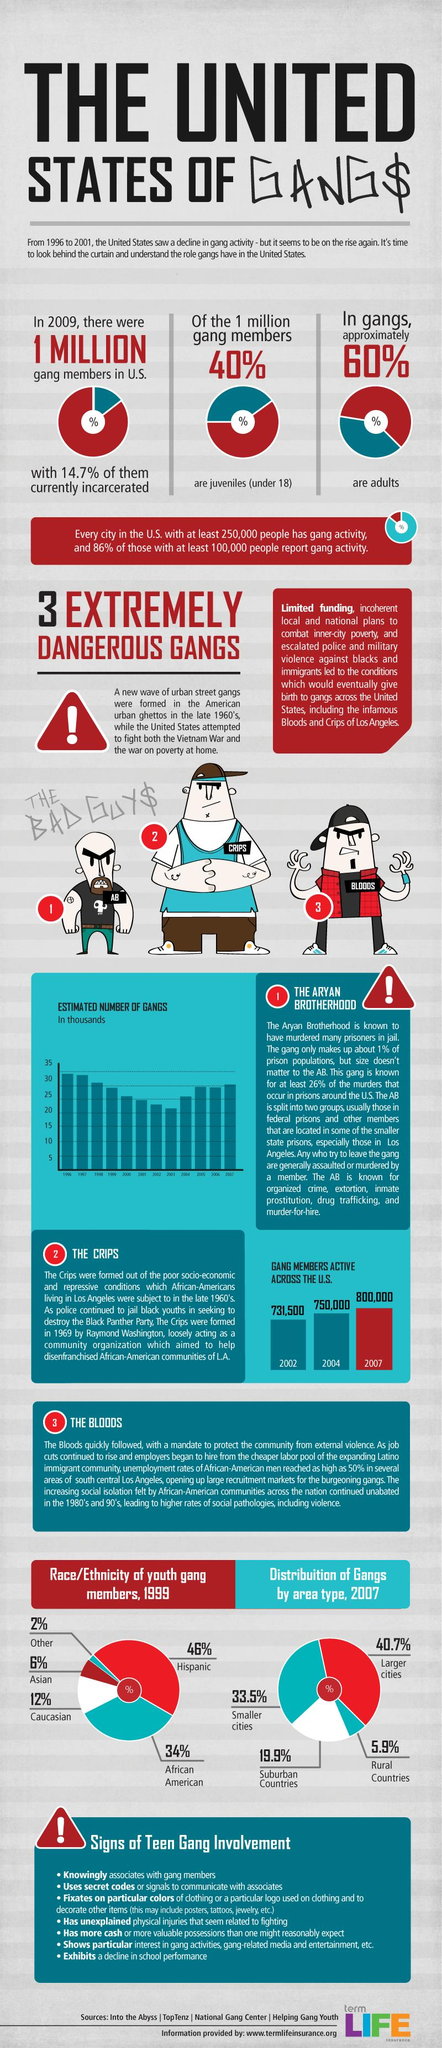Highlight a few significant elements in this photo. There are seven points that come under the signs of teen gang involvement. According to the data, rural areas have the least concentration of gangs compared to other areas, such as urban and suburban areas. The total percentage distribution of gangs by area type is 100%. The total percentage of youth gang members in 1999 was 100%. According to the given information, the percentage difference in gang members between Hispanic and African American populations is 12%. 